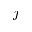<formula> <loc_0><loc_0><loc_500><loc_500>j</formula> 